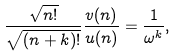<formula> <loc_0><loc_0><loc_500><loc_500>\frac { \sqrt { n ! } } { \sqrt { ( n + k ) ! } } \frac { v ( n ) } { u ( n ) } = \frac { 1 } { \omega ^ { k } } ,</formula> 